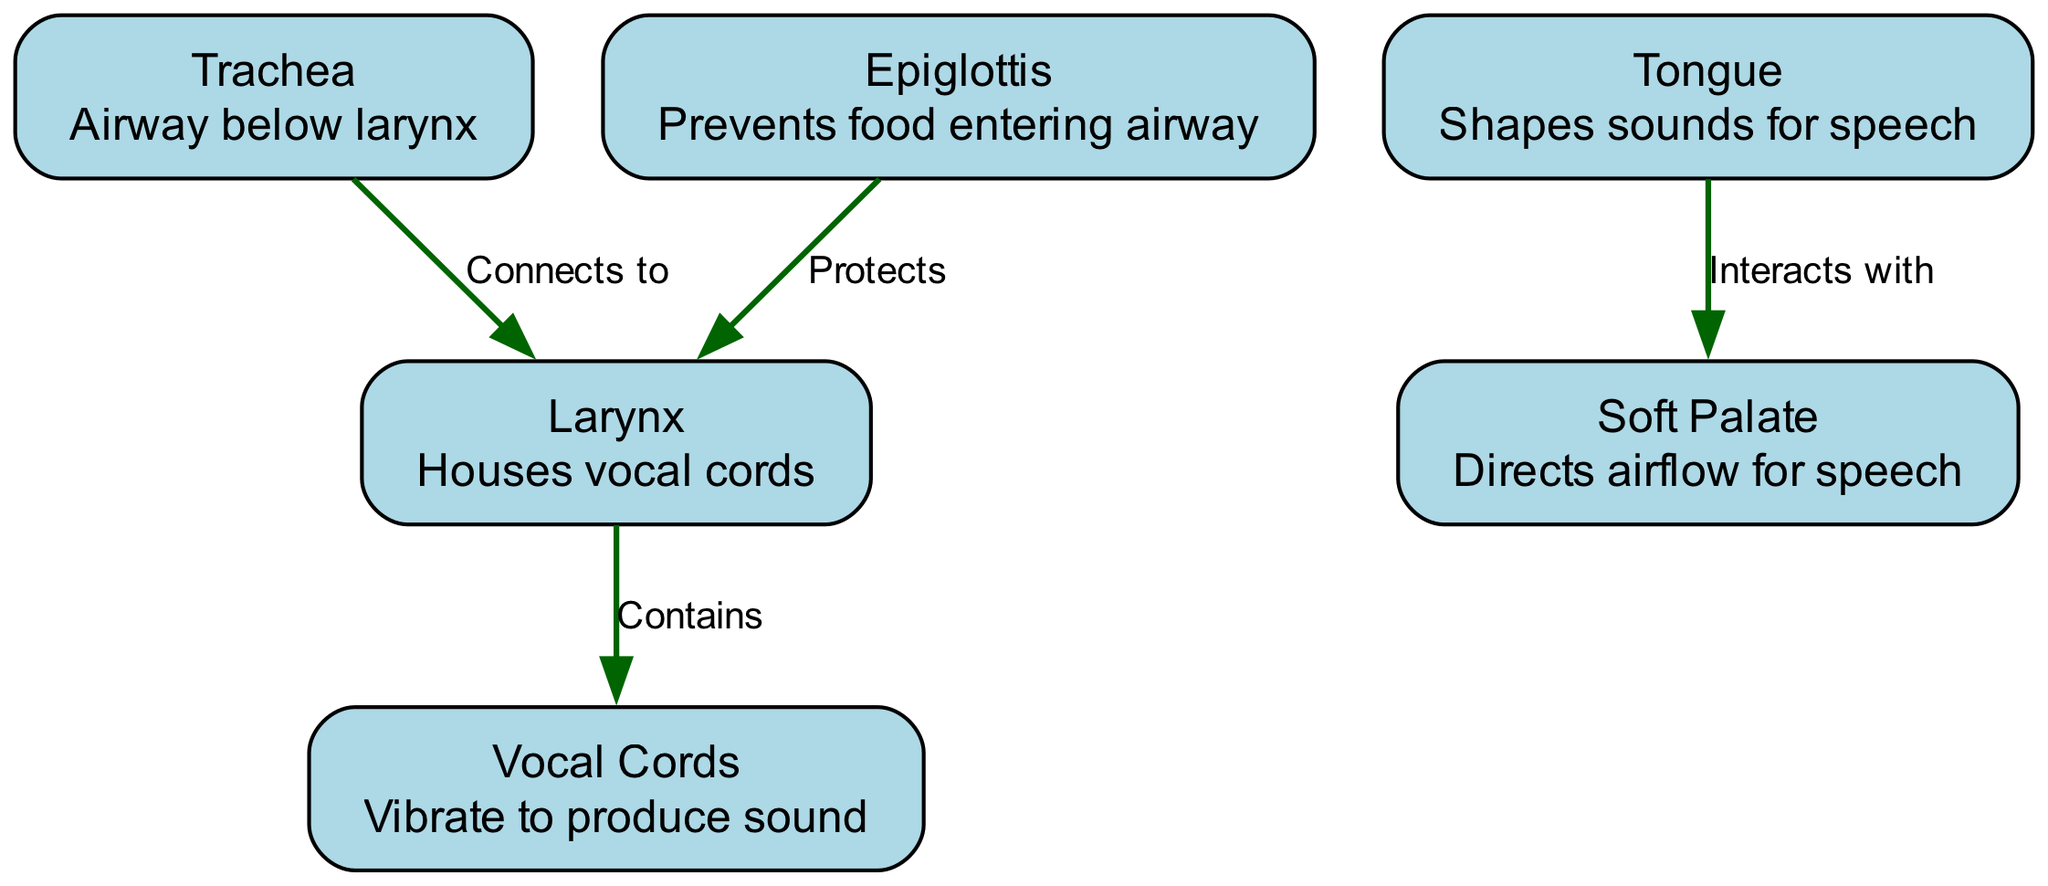What are the vocal cords responsible for? The diagram shows that the vocal cords vibrate to produce sound, which is explicitly stated in their description.
Answer: Produce sound How many nodes are present in the diagram? The diagram includes six nodes: vocal cords, larynx, trachea, epiglottis, tongue, and soft palate. Counting these nodes provides the total.
Answer: 6 What structure protects the larynx? According to the diagram, the epiglottis protects the larynx, as indicated by the connection labeled "Protects."
Answer: Epiglottis What do the vocal cords reside in? The diagram specifies that the larynx houses the vocal cords, which is detailed in the edge labeled "Contains."
Answer: Larynx What part connects to the larynx? The trachea is connected to the larynx, as shown by the edge labeled "Connects to." This clearly indicates the relationship between these two structures.
Answer: Trachea How does the tongue interact with the soft palate? The diagram indicates that the tongue interacts with the soft palate, which is essential for shaping sounds for speech. This interaction is explicitly marked in the edge label "Interacts with."
Answer: Interacts Which structure directs airflow for speech? The soft palate is responsible for directing airflow for speech, as mentioned in its description. Analyzing the nodes allows us to identify this function clearly.
Answer: Soft Palate How many edges are present in the diagram? There are four edges shown in the diagram, representing the connections and relationships between different nodes. Counting these edges gives the total.
Answer: 4 What role does the tongue play in speech production? The diagram describes the tongue as shaping sounds for speech, highlighting its critical function in this process. Thus, the role is clear from its description.
Answer: Shapes sounds 